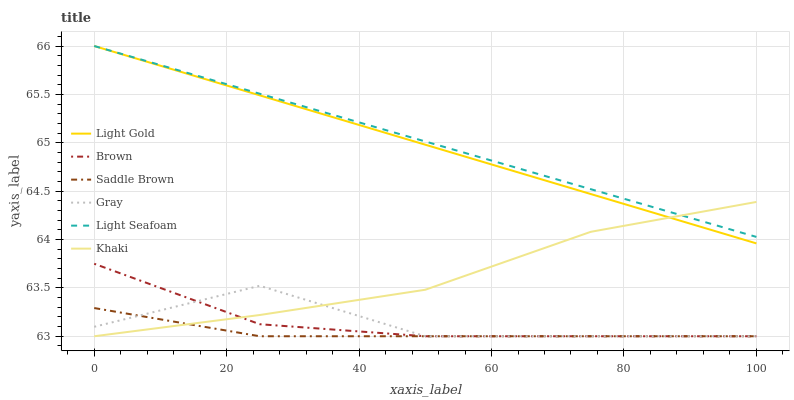Does Saddle Brown have the minimum area under the curve?
Answer yes or no. Yes. Does Light Seafoam have the maximum area under the curve?
Answer yes or no. Yes. Does Khaki have the minimum area under the curve?
Answer yes or no. No. Does Khaki have the maximum area under the curve?
Answer yes or no. No. Is Light Gold the smoothest?
Answer yes or no. Yes. Is Gray the roughest?
Answer yes or no. Yes. Is Khaki the smoothest?
Answer yes or no. No. Is Khaki the roughest?
Answer yes or no. No. Does Brown have the lowest value?
Answer yes or no. Yes. Does Light Seafoam have the lowest value?
Answer yes or no. No. Does Light Gold have the highest value?
Answer yes or no. Yes. Does Khaki have the highest value?
Answer yes or no. No. Is Gray less than Light Seafoam?
Answer yes or no. Yes. Is Light Seafoam greater than Gray?
Answer yes or no. Yes. Does Light Seafoam intersect Light Gold?
Answer yes or no. Yes. Is Light Seafoam less than Light Gold?
Answer yes or no. No. Is Light Seafoam greater than Light Gold?
Answer yes or no. No. Does Gray intersect Light Seafoam?
Answer yes or no. No. 